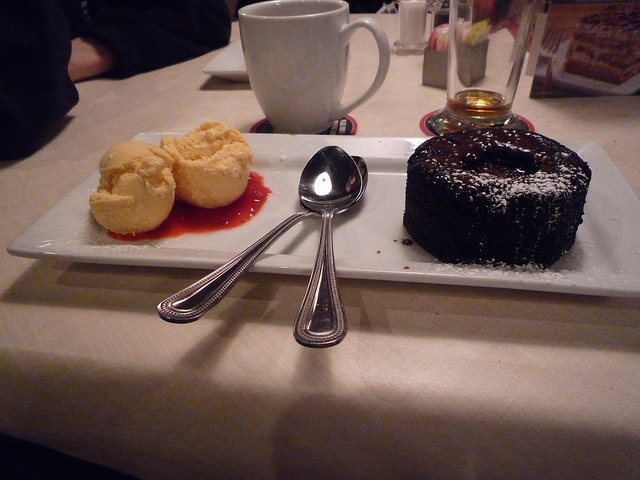Describe the objects in this image and their specific colors. I can see dining table in black, darkgray, gray, and maroon tones, cake in black, gray, and darkgray tones, people in black, maroon, and brown tones, cup in black, gray, darkgray, and tan tones, and cup in black, maroon, brown, darkgray, and gray tones in this image. 